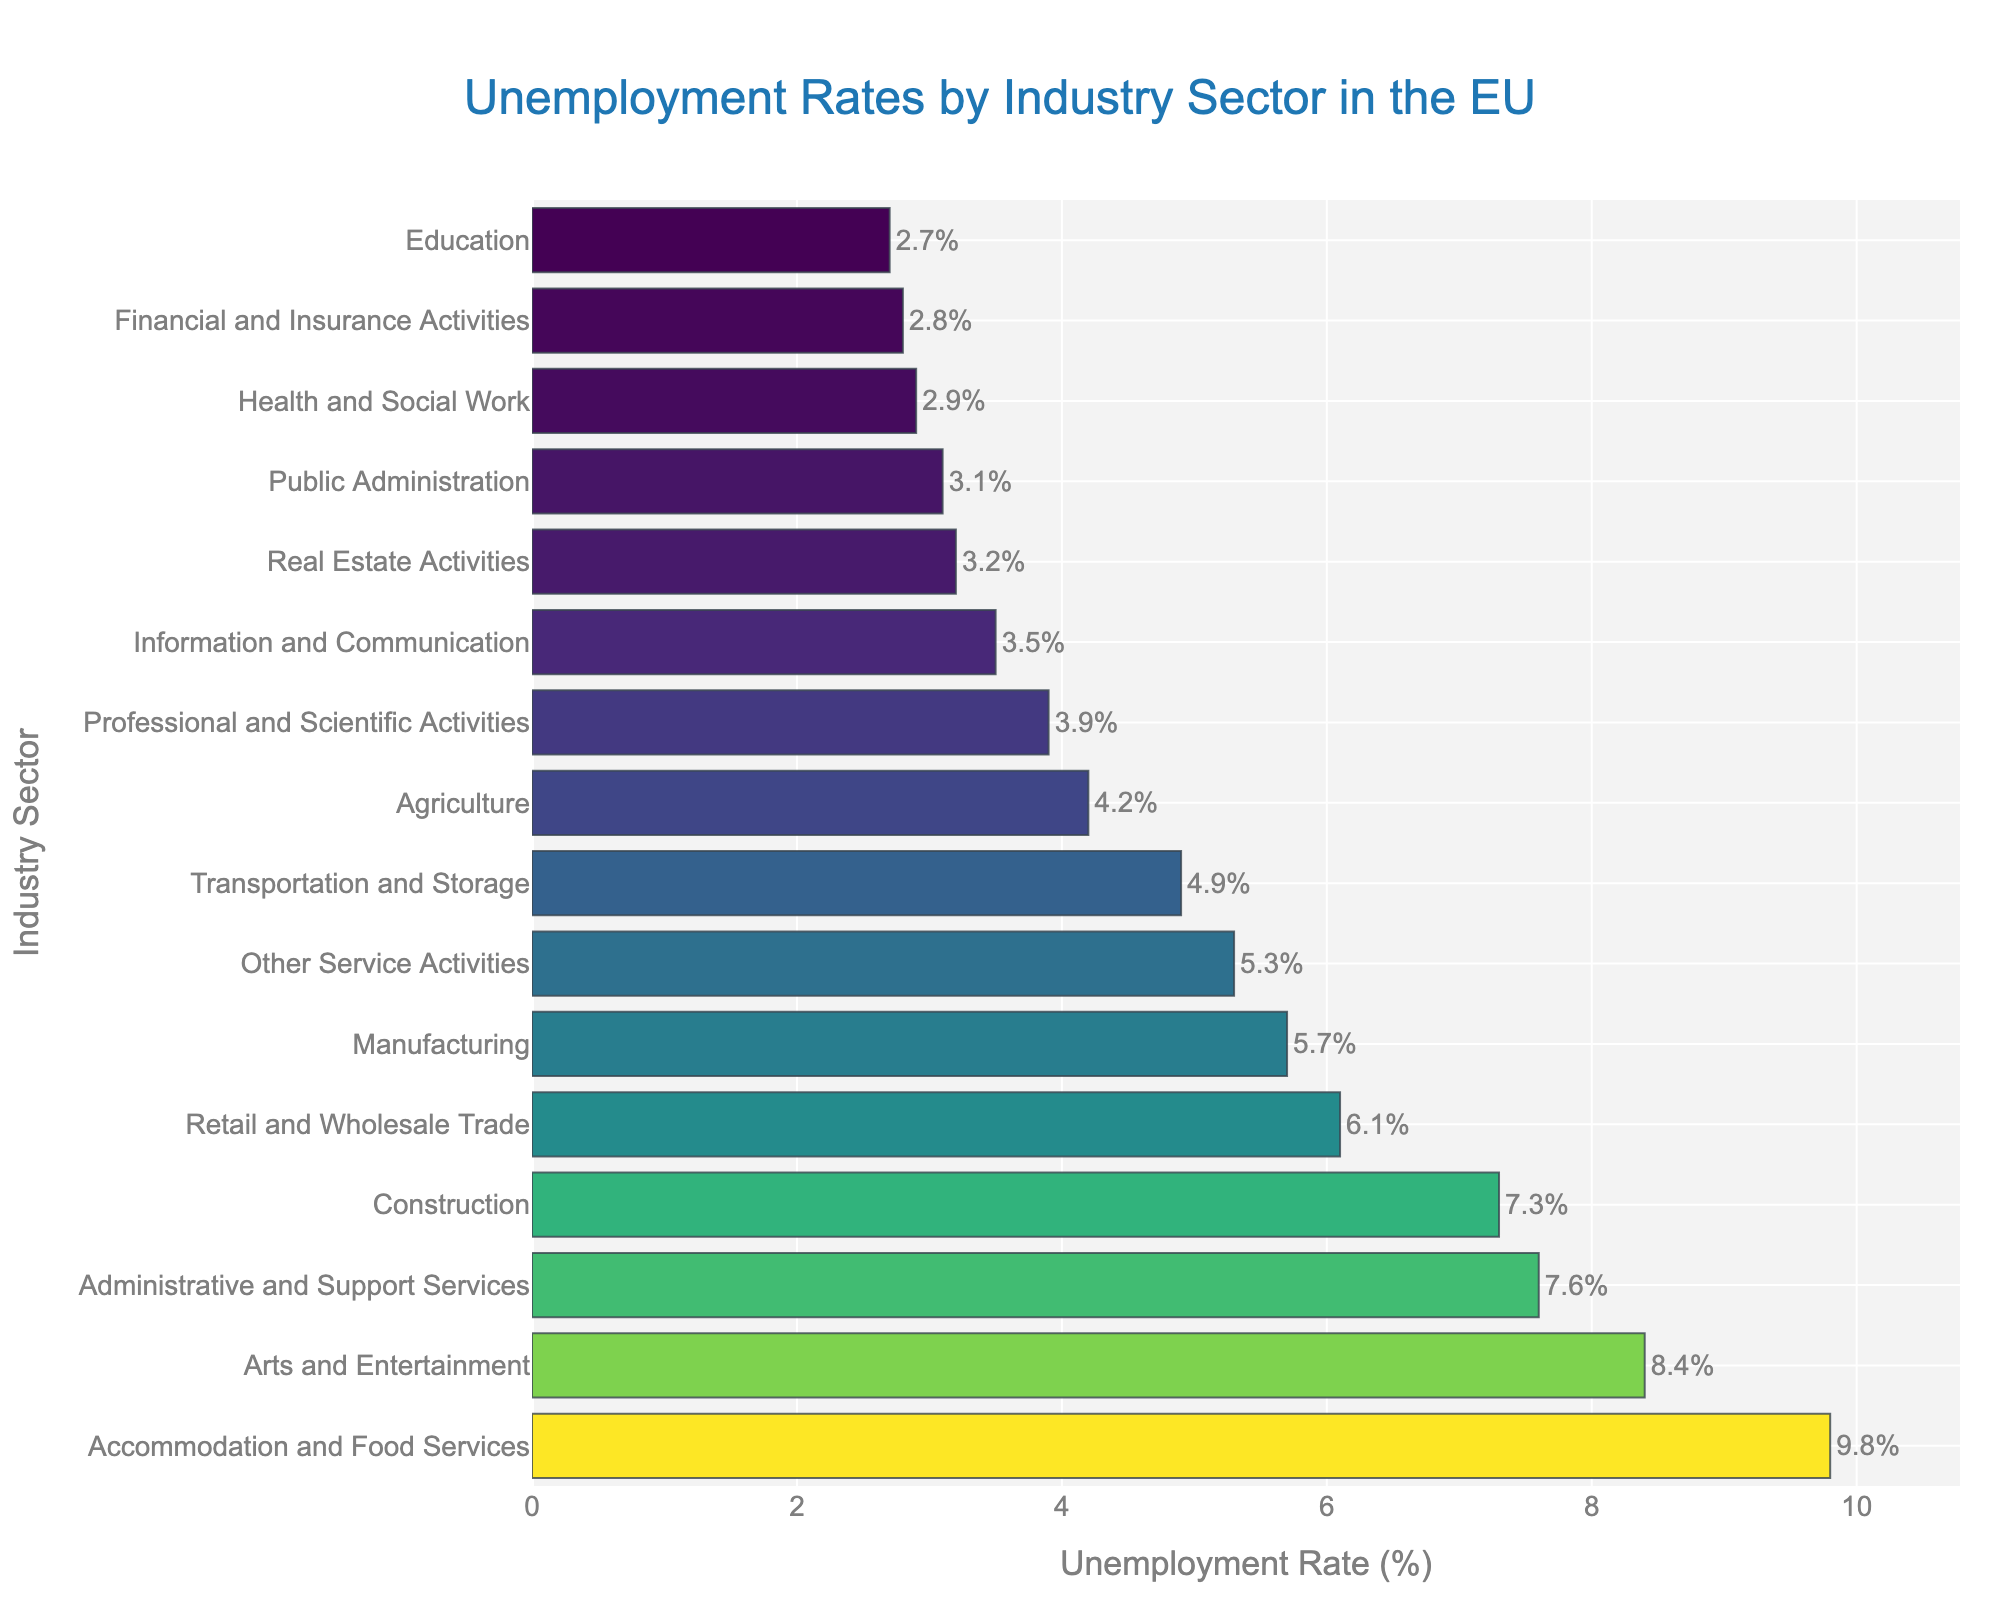What's the industry sector with the highest unemployment rate? To determine which industry has the highest unemployment rate, look for the bar with the greatest length. The "Accommodation and Food Services" sector has the longest bar, indicating the highest unemployment rate.
Answer: Accommodation and Food Services Which sector has a lower unemployment rate: Retail and Wholesale Trade or Construction? Compare the lengths of the bars for "Retail and Wholesale Trade" and "Construction." The bar for "Retail and Wholesale Trade" is shorter than that for "Construction," meaning its unemployment rate is lower.
Answer: Retail and Wholesale Trade What's the unemployment rate difference between Arts and Entertainment and Agriculture? To find the difference, subtract Agriculture's unemployment rate (4.2%) from Arts and Entertainment's unemployment rate (8.4%).
Answer: 4.2% What is the average unemployment rate of Public Administration, Health and Social Work, and Education sectors? Add the unemployment rates of Public Administration (3.1%), Health and Social Work (2.9%), and Education (2.7%), then divide by 3: (3.1 + 2.9 + 2.7) / 3.
Answer: 2.9% Is the unemployment rate in Manufacturing higher than in Transportation and Storage? Compare the lengths of the bars for "Manufacturing" and "Transportation and Storage." The bar for "Manufacturing" is longer, indicating a higher unemployment rate.
Answer: Yes Which sector has the closest unemployment rate to 5%? Look for the bar closest to the 5% mark on the x-axis. The "Transportation and Storage" sector has an unemployment rate of 4.9%, which is the closest.
Answer: Transportation and Storage Are there more sectors with unemployment rates above or below 5%? Count the bars above 5% and those below 5%. There are 6 sectors above 5% (Construction, Retail and Wholesale Trade, Accommodation and Food Services, Administrative and Support Services, Arts and Entertainment, Other Service Activities) and 10 sectors below 5%.
Answer: Below Which sector has the lowest unemployment rate? Find the shortest bar on the chart. The "Education" sector has the shortest bar, indicating the lowest unemployment rate.
Answer: Education How much higher is the unemployment rate in Administrative and Support Services compared to Information and Communication? Subtract the unemployment rate of Information and Communication (3.5%) from that of Administrative and Support Services (7.6%).
Answer: 4.1% What is the range of unemployment rates shown in the chart? Subtract the smallest unemployment rate (Education, 2.7%) from the largest unemployment rate (Accommodation and Food Services, 9.8%).
Answer: 7.1% 